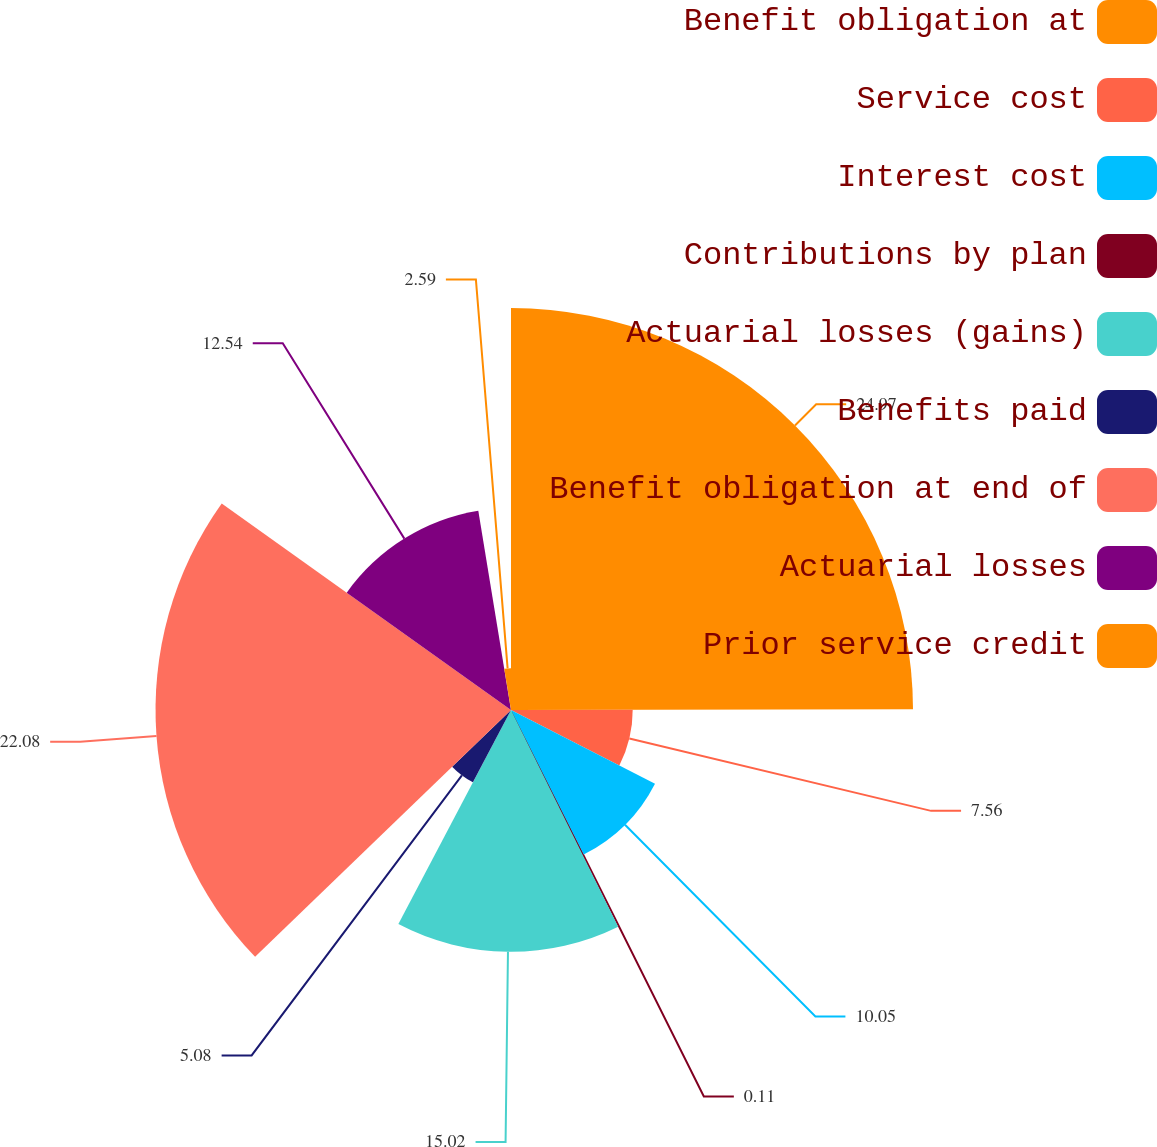Convert chart. <chart><loc_0><loc_0><loc_500><loc_500><pie_chart><fcel>Benefit obligation at<fcel>Service cost<fcel>Interest cost<fcel>Contributions by plan<fcel>Actuarial losses (gains)<fcel>Benefits paid<fcel>Benefit obligation at end of<fcel>Actuarial losses<fcel>Prior service credit<nl><fcel>24.97%<fcel>7.56%<fcel>10.05%<fcel>0.11%<fcel>15.02%<fcel>5.08%<fcel>22.08%<fcel>12.54%<fcel>2.59%<nl></chart> 